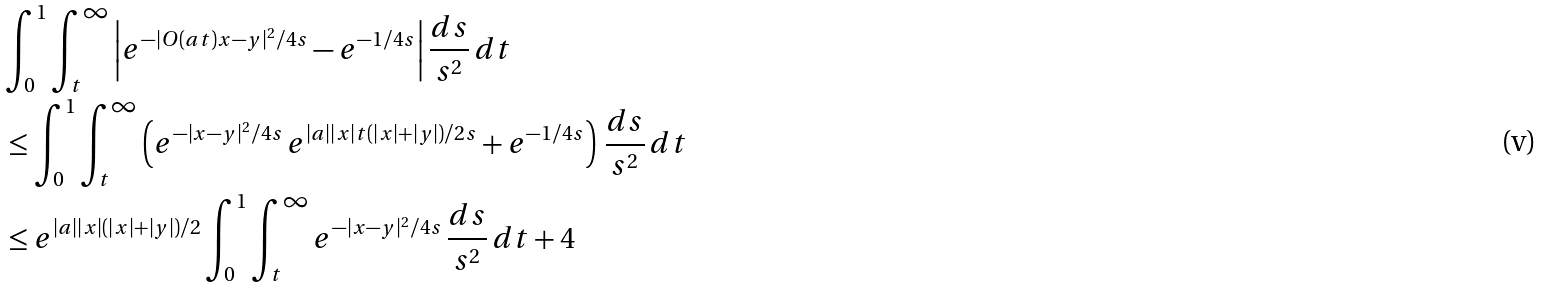<formula> <loc_0><loc_0><loc_500><loc_500>& \int _ { 0 } ^ { 1 } \int _ { t } ^ { \infty } \left | e ^ { - | O ( a t ) x - y | ^ { 2 } / 4 s } - e ^ { - 1 / 4 s } \right | \frac { d s } { s ^ { 2 } } \, d t \\ & \leq \int _ { 0 } ^ { 1 } \int _ { t } ^ { \infty } \left ( e ^ { - | x - y | ^ { 2 } / 4 s } \, e ^ { | a | | x | t ( | x | + | y | ) / 2 s } + e ^ { - 1 / 4 s } \right ) \, \frac { d s } { s ^ { 2 } } \, d t \\ & \leq e ^ { | a | | x | ( | x | + | y | ) / 2 } \int _ { 0 } ^ { 1 } \int _ { t } ^ { \infty } e ^ { - | x - y | ^ { 2 } / 4 s } \, \frac { d s } { s ^ { 2 } } \, d t + 4</formula> 